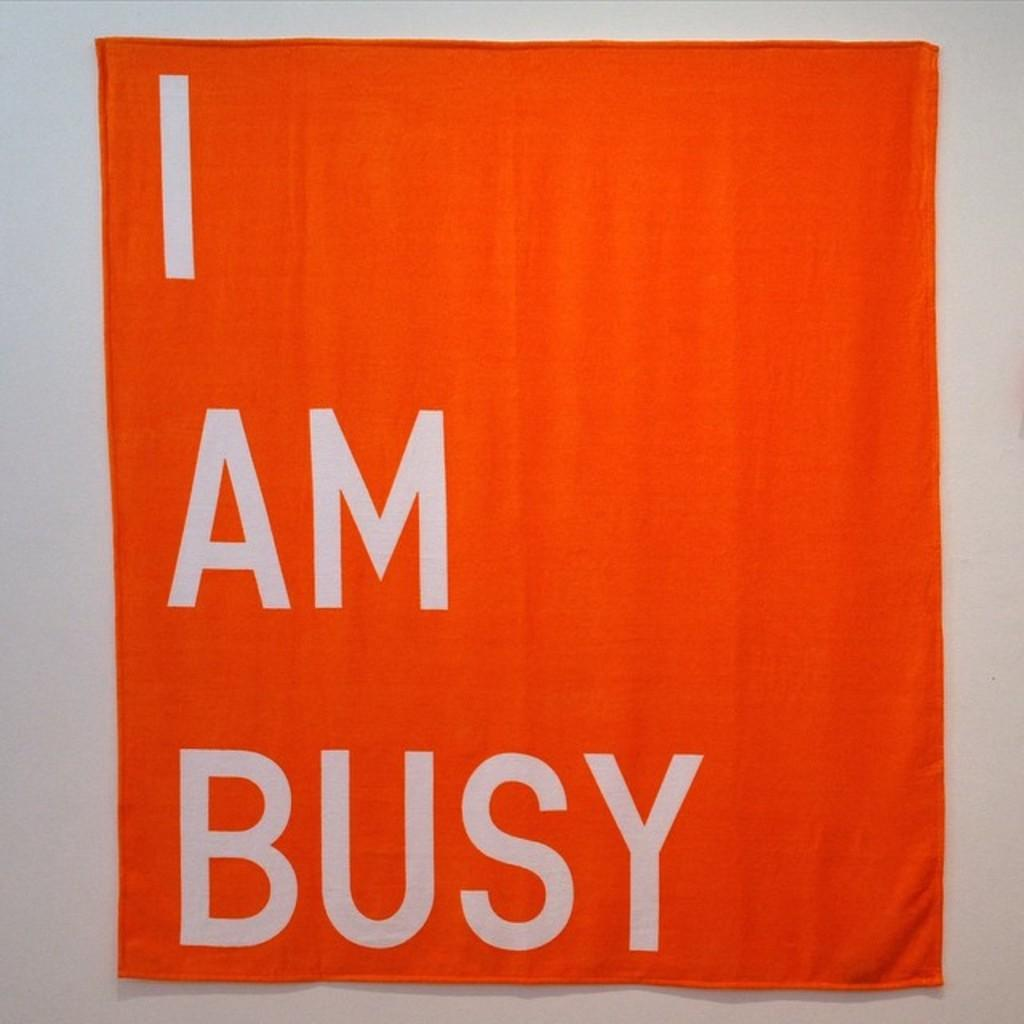<image>
Relay a brief, clear account of the picture shown. an orange napkin that says I am busy 